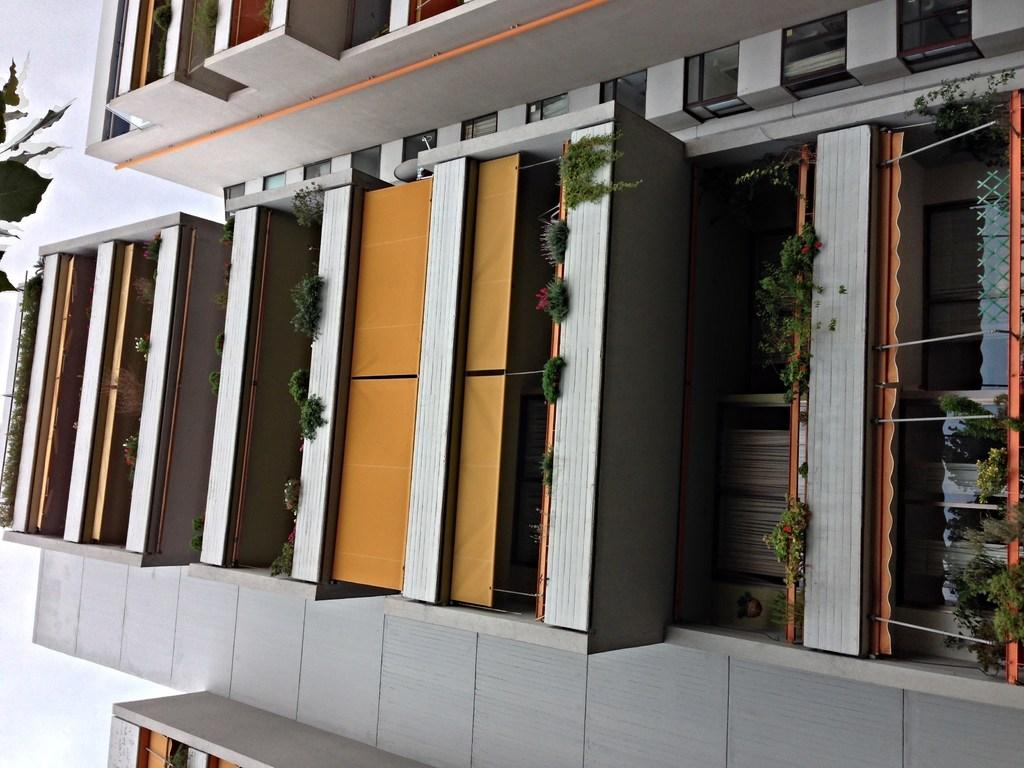What type of structure is visible in the image? There is a building in the image. What type of plants can be seen in the image? There are house plants and creeping plants present in the image. What is the condition of the sky in the image? The sky is clear in the image. What is the opinion of the throne in the image? There is no throne present in the image, so it is not possible to determine its opinion. 